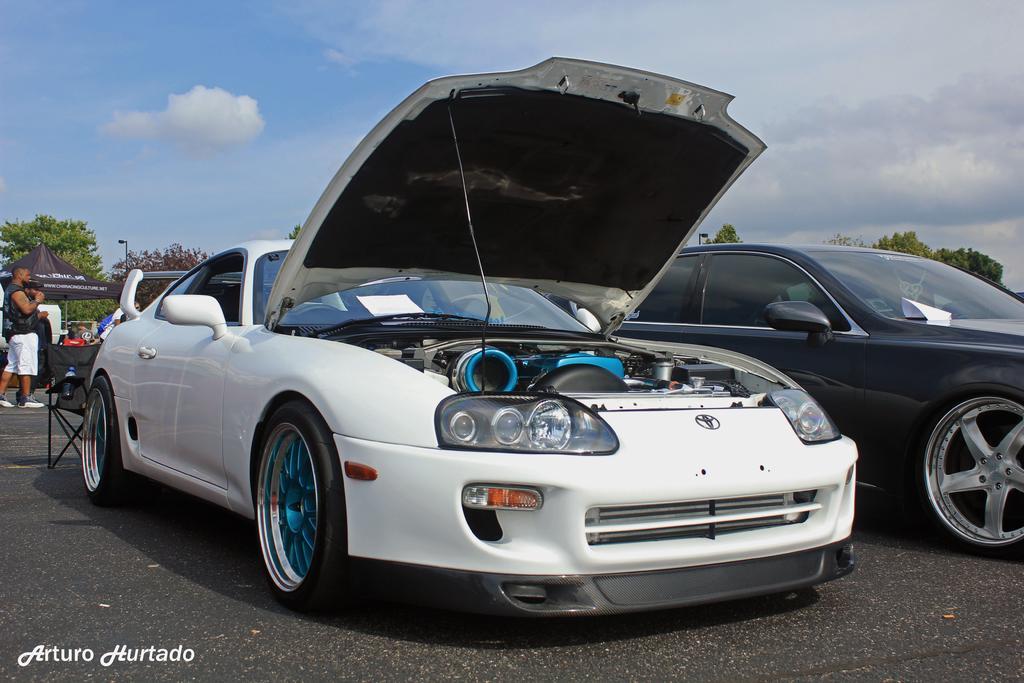Can you describe this image briefly? In this image I can see two vehicles and the vehicles are in white and black color. Background I can see few persons, a tent in black color, trees in green color, few light poles and the sky is white and blue color. 